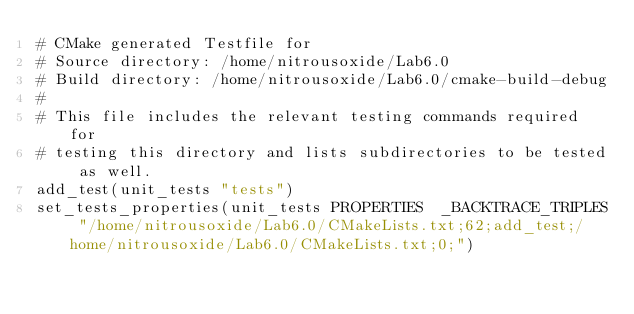Convert code to text. <code><loc_0><loc_0><loc_500><loc_500><_CMake_># CMake generated Testfile for 
# Source directory: /home/nitrousoxide/Lab6.0
# Build directory: /home/nitrousoxide/Lab6.0/cmake-build-debug
# 
# This file includes the relevant testing commands required for 
# testing this directory and lists subdirectories to be tested as well.
add_test(unit_tests "tests")
set_tests_properties(unit_tests PROPERTIES  _BACKTRACE_TRIPLES "/home/nitrousoxide/Lab6.0/CMakeLists.txt;62;add_test;/home/nitrousoxide/Lab6.0/CMakeLists.txt;0;")
</code> 